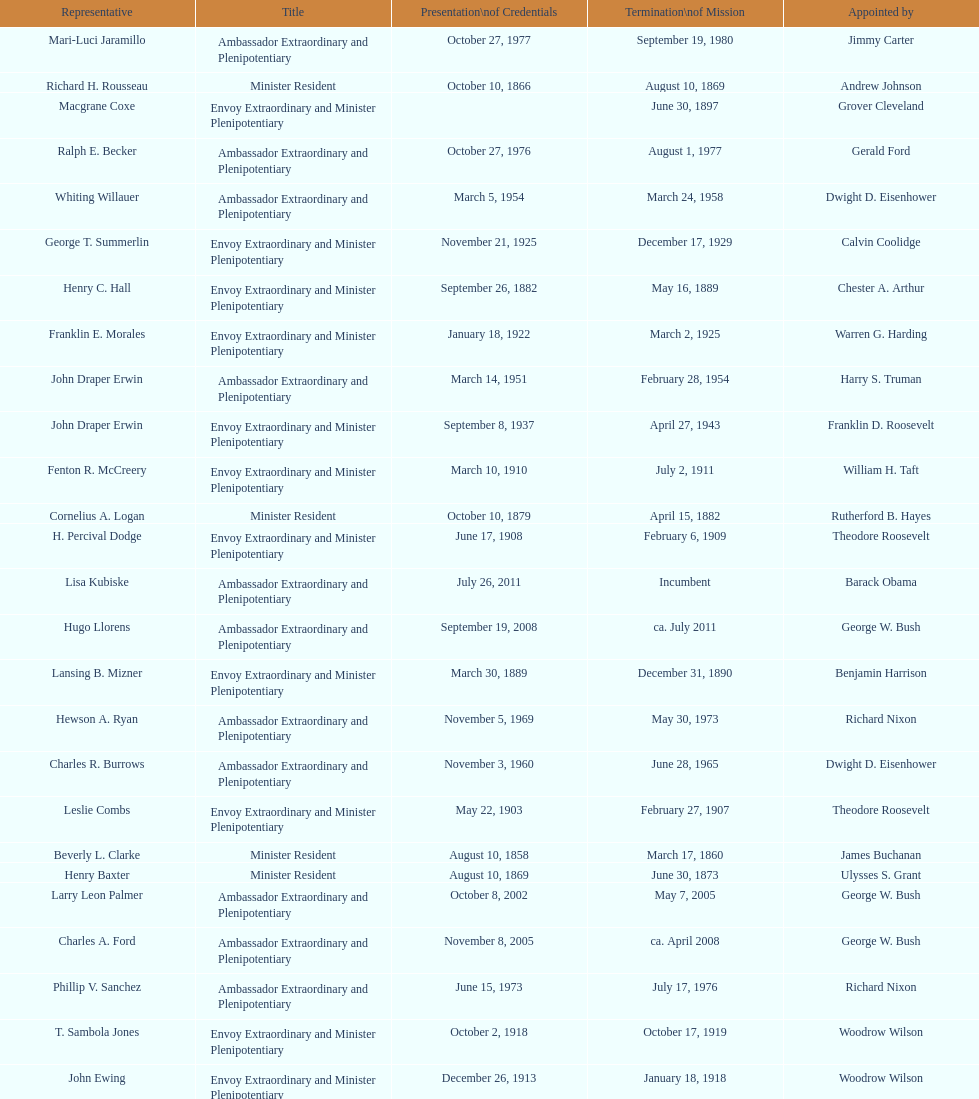Could you parse the entire table? {'header': ['Representative', 'Title', 'Presentation\\nof Credentials', 'Termination\\nof Mission', 'Appointed by'], 'rows': [['Mari-Luci Jaramillo', 'Ambassador Extraordinary and Plenipotentiary', 'October 27, 1977', 'September 19, 1980', 'Jimmy Carter'], ['Richard H. Rousseau', 'Minister Resident', 'October 10, 1866', 'August 10, 1869', 'Andrew Johnson'], ['Macgrane Coxe', 'Envoy Extraordinary and Minister Plenipotentiary', '', 'June 30, 1897', 'Grover Cleveland'], ['Ralph E. Becker', 'Ambassador Extraordinary and Plenipotentiary', 'October 27, 1976', 'August 1, 1977', 'Gerald Ford'], ['Whiting Willauer', 'Ambassador Extraordinary and Plenipotentiary', 'March 5, 1954', 'March 24, 1958', 'Dwight D. Eisenhower'], ['George T. Summerlin', 'Envoy Extraordinary and Minister Plenipotentiary', 'November 21, 1925', 'December 17, 1929', 'Calvin Coolidge'], ['Henry C. Hall', 'Envoy Extraordinary and Minister Plenipotentiary', 'September 26, 1882', 'May 16, 1889', 'Chester A. Arthur'], ['Franklin E. Morales', 'Envoy Extraordinary and Minister Plenipotentiary', 'January 18, 1922', 'March 2, 1925', 'Warren G. Harding'], ['John Draper Erwin', 'Ambassador Extraordinary and Plenipotentiary', 'March 14, 1951', 'February 28, 1954', 'Harry S. Truman'], ['John Draper Erwin', 'Envoy Extraordinary and Minister Plenipotentiary', 'September 8, 1937', 'April 27, 1943', 'Franklin D. Roosevelt'], ['Fenton R. McCreery', 'Envoy Extraordinary and Minister Plenipotentiary', 'March 10, 1910', 'July 2, 1911', 'William H. Taft'], ['Cornelius A. Logan', 'Minister Resident', 'October 10, 1879', 'April 15, 1882', 'Rutherford B. Hayes'], ['H. Percival Dodge', 'Envoy Extraordinary and Minister Plenipotentiary', 'June 17, 1908', 'February 6, 1909', 'Theodore Roosevelt'], ['Lisa Kubiske', 'Ambassador Extraordinary and Plenipotentiary', 'July 26, 2011', 'Incumbent', 'Barack Obama'], ['Hugo Llorens', 'Ambassador Extraordinary and Plenipotentiary', 'September 19, 2008', 'ca. July 2011', 'George W. Bush'], ['Lansing B. Mizner', 'Envoy Extraordinary and Minister Plenipotentiary', 'March 30, 1889', 'December 31, 1890', 'Benjamin Harrison'], ['Hewson A. Ryan', 'Ambassador Extraordinary and Plenipotentiary', 'November 5, 1969', 'May 30, 1973', 'Richard Nixon'], ['Charles R. Burrows', 'Ambassador Extraordinary and Plenipotentiary', 'November 3, 1960', 'June 28, 1965', 'Dwight D. Eisenhower'], ['Leslie Combs', 'Envoy Extraordinary and Minister Plenipotentiary', 'May 22, 1903', 'February 27, 1907', 'Theodore Roosevelt'], ['Beverly L. Clarke', 'Minister Resident', 'August 10, 1858', 'March 17, 1860', 'James Buchanan'], ['Henry Baxter', 'Minister Resident', 'August 10, 1869', 'June 30, 1873', 'Ulysses S. Grant'], ['Larry Leon Palmer', 'Ambassador Extraordinary and Plenipotentiary', 'October 8, 2002', 'May 7, 2005', 'George W. Bush'], ['Charles A. Ford', 'Ambassador Extraordinary and Plenipotentiary', 'November 8, 2005', 'ca. April 2008', 'George W. Bush'], ['Phillip V. Sanchez', 'Ambassador Extraordinary and Plenipotentiary', 'June 15, 1973', 'July 17, 1976', 'Richard Nixon'], ['T. Sambola Jones', 'Envoy Extraordinary and Minister Plenipotentiary', 'October 2, 1918', 'October 17, 1919', 'Woodrow Wilson'], ['John Ewing', 'Envoy Extraordinary and Minister Plenipotentiary', 'December 26, 1913', 'January 18, 1918', 'Woodrow Wilson'], ['Jack R. Binns', 'Ambassador Extraordinary and Plenipotentiary', 'October 10, 1980', 'October 31, 1981', 'Jimmy Carter'], ['Philip Marshall Brown', 'Envoy Extraordinary and Minister Plenipotentiary', 'February 21, 1909', 'February 26, 1910', 'Theodore Roosevelt'], ['Pierce M. B. Young', 'Envoy Extraordinary and Minister Plenipotentiary', 'November 12, 1893', 'May 23, 1896', 'Grover Cleveland'], ['Romualdo Pacheco', 'Envoy Extraordinary and Minister Plenipotentiary', 'April 17, 1891', 'June 12, 1893', 'Benjamin Harrison'], ['Joseph J. Jova', 'Ambassador Extraordinary and Plenipotentiary', 'July 12, 1965', 'June 21, 1969', 'Lyndon B. Johnson'], ['Charles Dunning White', 'Envoy Extraordinary and Minister Plenipotentiary', 'September 9, 1911', 'November 4, 1913', 'William H. Taft'], ['W. Godfrey Hunter', 'Envoy Extraordinary and Minister Plenipotentiary', 'January 19, 1899', 'February 2, 1903', 'William McKinley'], ['Henry C. Hall', 'Minister Resident', 'April 21, 1882', 'September 26, 1882', 'Chester A. Arthur'], ['Frank Almaguer', 'Ambassador Extraordinary and Plenipotentiary', 'August 25, 1999', 'September 5, 2002', 'Bill Clinton'], ['Paul C. Daniels', 'Ambassador Extraordinary and Plenipotentiary', 'June 23, 1947', 'October 30, 1947', 'Harry S. Truman'], ['Cresencio S. Arcos, Jr.', 'Ambassador Extraordinary and Plenipotentiary', 'January 29, 1990', 'July 1, 1993', 'George H. W. Bush'], ['John Arthur Ferch', 'Ambassador Extraordinary and Plenipotentiary', 'August 22, 1985', 'July 9, 1986', 'Ronald Reagan'], ['John Draper Erwin', 'Ambassador Extraordinary and Plenipotentiary', 'April 27, 1943', 'April 16, 1947', 'Franklin D. Roosevelt'], ['Herbert S. Bursley', 'Ambassador Extraordinary and Plenipotentiary', 'May 15, 1948', 'December 12, 1950', 'Harry S. Truman'], ['Thomas H. Clay', 'Minister Resident', 'April 5, 1864', 'August 10, 1866', 'Abraham Lincoln'], ['Everett Ellis Briggs', 'Ambassador Extraordinary and Plenipotentiary', 'November 4, 1986', 'June 15, 1989', 'Ronald Reagan'], ['James R. Partridge', 'Minister Resident', 'April 25, 1862', 'November 14, 1862', 'Abraham Lincoln'], ['James F. Creagan', 'Ambassador Extraordinary and Plenipotentiary', 'August 29, 1996', 'July 20, 1999', 'Bill Clinton'], ['George Williamson', 'Minister Resident', 'February 19, 1874', 'January 31, 1879', 'Ulysses S. Grant'], ['Joseph W. J. Lee', 'Envoy Extraordinary and Minister Plenipotentiary', '', 'July 1, 1907', 'Theodore Roosevelt'], ['Robert Newbegin', 'Ambassador Extraordinary and Plenipotentiary', 'April 30, 1958', 'August 3, 1960', 'Dwight D. Eisenhower'], ['John D. Negroponte', 'Ambassador Extraordinary and Plenipotentiary', 'November 11, 1981', 'May 30, 1985', 'Ronald Reagan'], ['Leo J. Keena', 'Envoy Extraordinary and Minister Plenipotentiary', 'July 19, 1935', 'May 1, 1937', 'Franklin D. Roosevelt'], ['Julius G. Lay', 'Envoy Extraordinary and Minister Plenipotentiary', 'May 31, 1930', 'March 17, 1935', 'Herbert Hoover'], ['Solon Borland', 'Envoy Extraordinary and Minister Plenipotentiary', '', 'April 17, 1854', 'Franklin Pierce'], ['William Thornton Pryce', 'Ambassador Extraordinary and Plenipotentiary', 'July 21, 1993', 'August 15, 1996', 'Bill Clinton']]} Which date precedes april 17, 1854? March 17, 1860. 